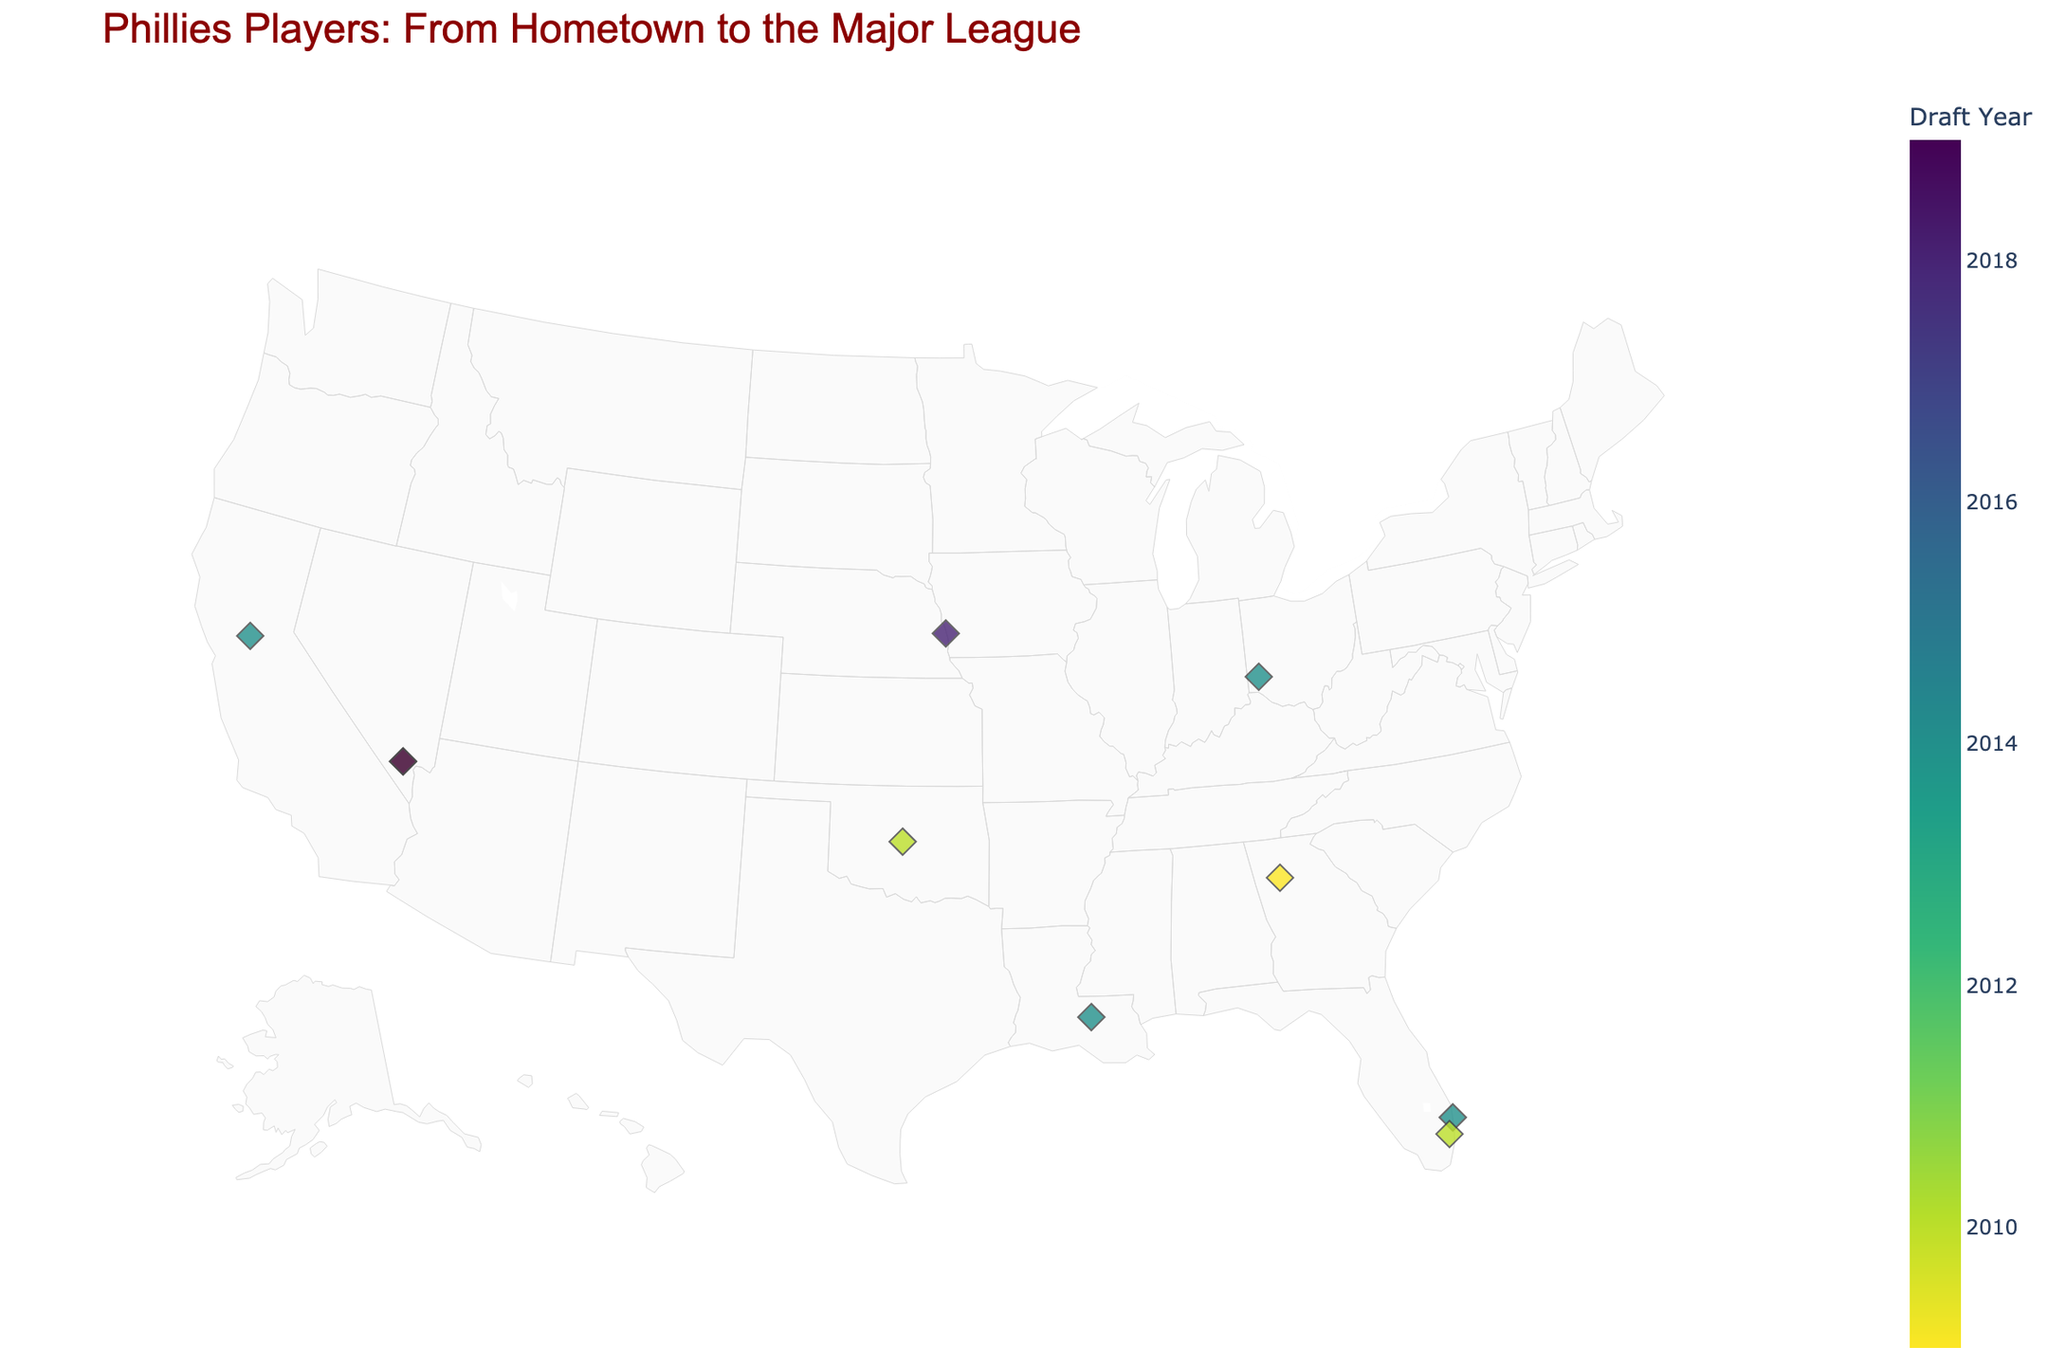How many players were drafted in 2014? Look at the color scale representing the draft years and count the markers corresponding to the year 2014. Specifically, identify the markers with the 2014 color and count them on the map.
Answer: 4 Which player's hometown is the farthest west? Identify the markers on the map and observe their longitude values. The player with the smallest (most negative) longitude is the farthest west.
Answer: Bryce Harper Are there any players from the same hometown? If so, who are they? Look for markers placed in the exact same location on the map and check their labels to see if they share the same hometown.
Answer: Bryce Harper and Bryson Stott Which state has the most players represented? Identify and count the number of players from each state based on the map markers and their locations. Compare the counts to find the state with the highest number.
Answer: Florida What is the range of draft years for the players? Note the earliest and latest draft years indicated by the color scale on the map and markers. Subtract the earliest year from the latest to find the range.
Answer: 2019 - 2009 = 10 years Which players debuted in the MLB within two years after being drafted? Identify players' draft years and their MLB debut years on the map. Compare the years to see if the difference is two years or less.
Answer: Bryce Harper, Kyle Schwarber, Trea Turner, Nola Which player had the longest time between their draft year and MLB debut? Compare the differences between draft years and MLB debut years for each player. Find the maximum difference.
Answer: J.T. Realmuto How many players have been drafted from states on the east coast of the USA? Identify the states considered part of the East Coast (e.g., Florida, Georgia) and count the number of players whose hometowns are in those states.
Answer: 3 Which players' markers are the closest geographically? Look at the markers on the map and find the two that are nearest to each other visually.
Answer: Bryce Harper and Bryson Stott 